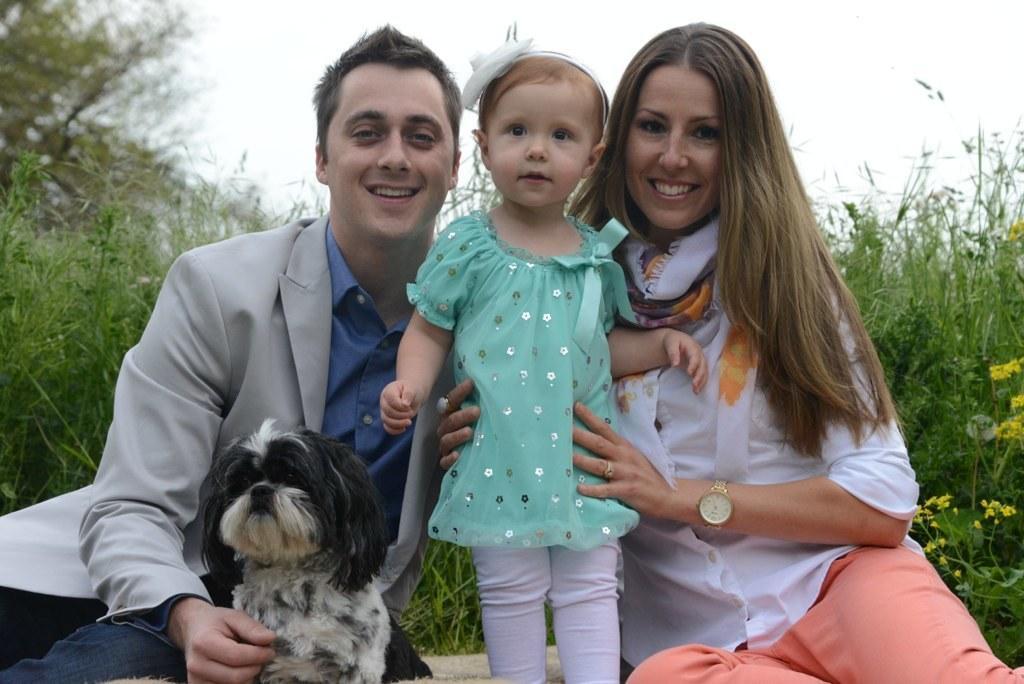In one or two sentences, can you explain what this image depicts? In this image there are three people and a dog. In the left a man wearing a grey coat and blue shirt is smiling. Beside him there is a little girl is wearing a green a top and and headband. In the right a lady wearing white shirt and orange pant is holding the baby and smiling. in the background there are plants. The sky is clear. 